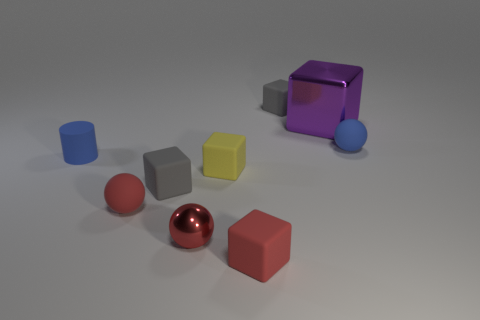Do the tiny cylinder and the sphere that is to the left of the small red metallic sphere have the same material?
Your response must be concise. Yes. How many purple things are either rubber objects or blocks?
Your response must be concise. 1. What size is the sphere that is the same material as the large thing?
Offer a terse response. Small. How many large things have the same shape as the tiny yellow matte object?
Your response must be concise. 1. Is the number of blue things that are behind the blue cylinder greater than the number of small matte spheres behind the purple metallic object?
Keep it short and to the point. Yes. Do the small shiny sphere and the matte ball that is in front of the tiny yellow rubber cube have the same color?
Your answer should be compact. Yes. There is another red sphere that is the same size as the red rubber sphere; what is it made of?
Provide a succinct answer. Metal. What number of objects are either gray rubber things or small matte blocks on the right side of the tiny metal object?
Ensure brevity in your answer.  4. There is a blue rubber cylinder; is its size the same as the shiny object that is on the right side of the small red metal thing?
Give a very brief answer. No. How many blocks are either yellow rubber objects or gray things?
Your answer should be very brief. 3. 